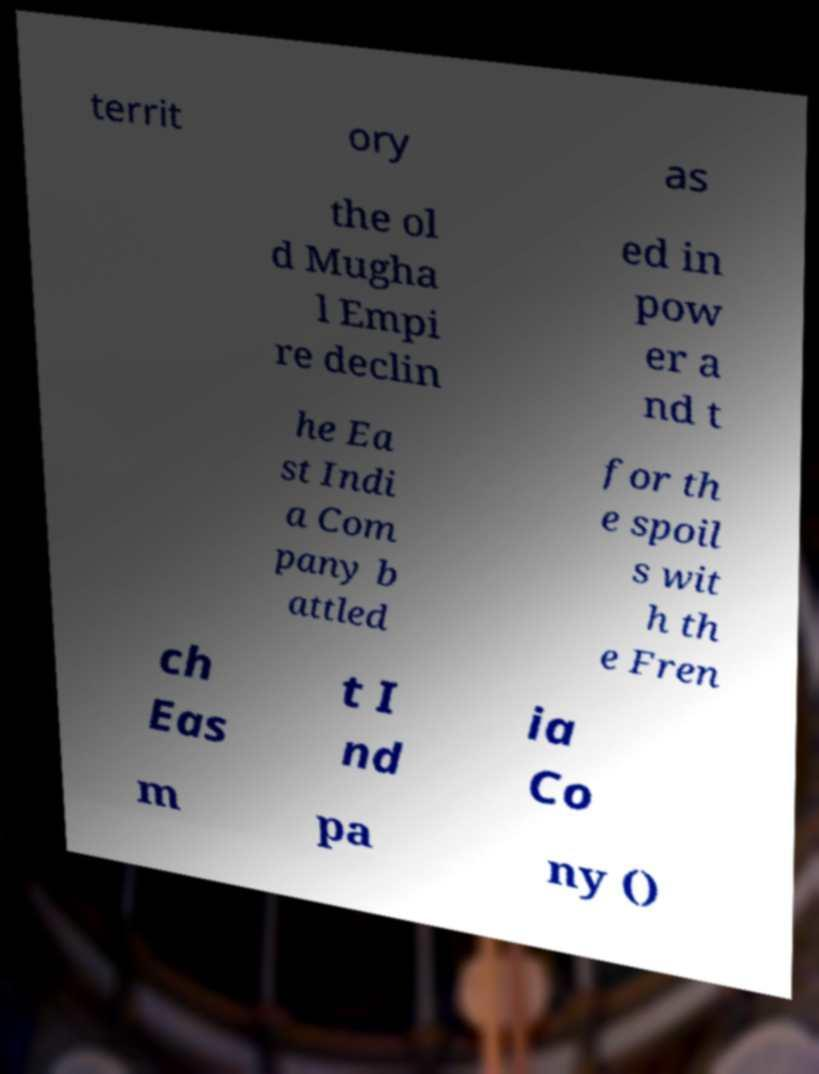Could you assist in decoding the text presented in this image and type it out clearly? territ ory as the ol d Mugha l Empi re declin ed in pow er a nd t he Ea st Indi a Com pany b attled for th e spoil s wit h th e Fren ch Eas t I nd ia Co m pa ny () 